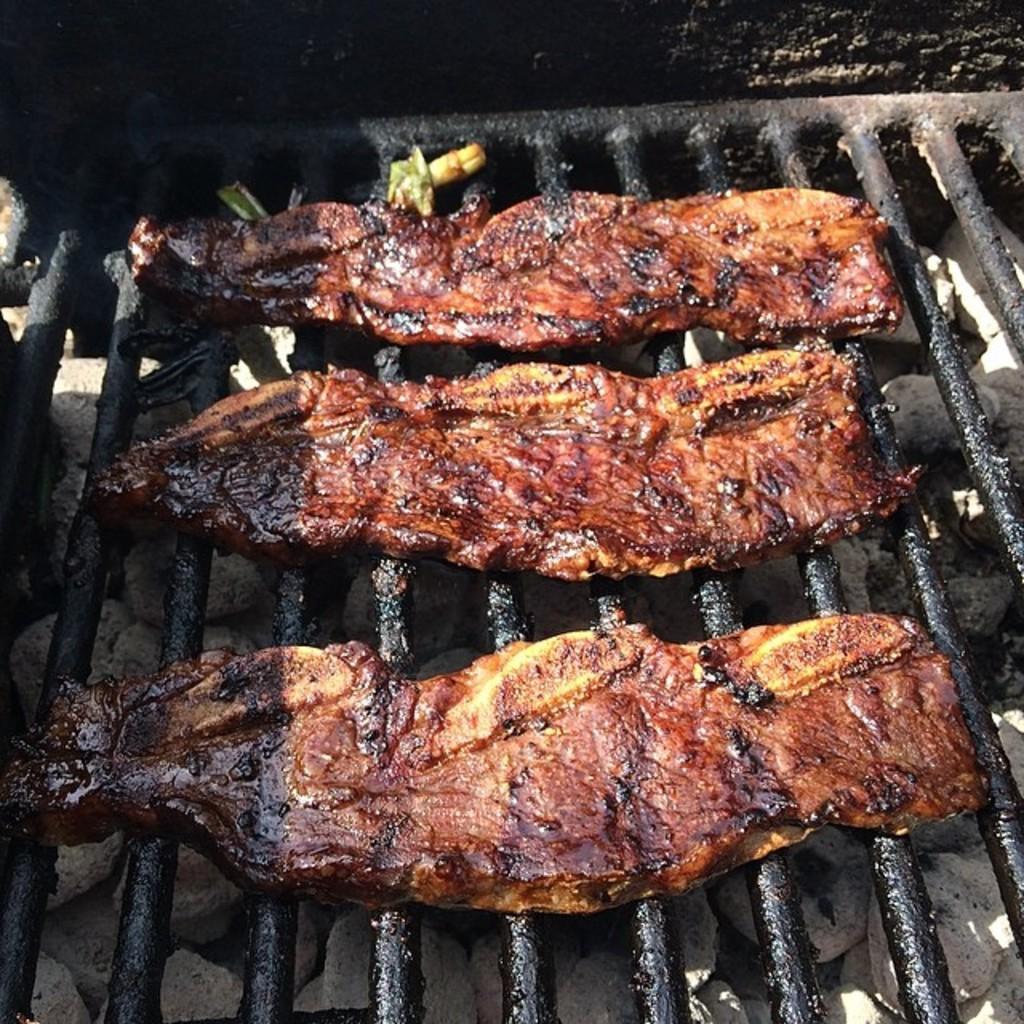How would you summarize this image in a sentence or two? In this image I can see the black colored metal grill and on the grill I can see few meat pieces which are yellow, brown and black in color. 